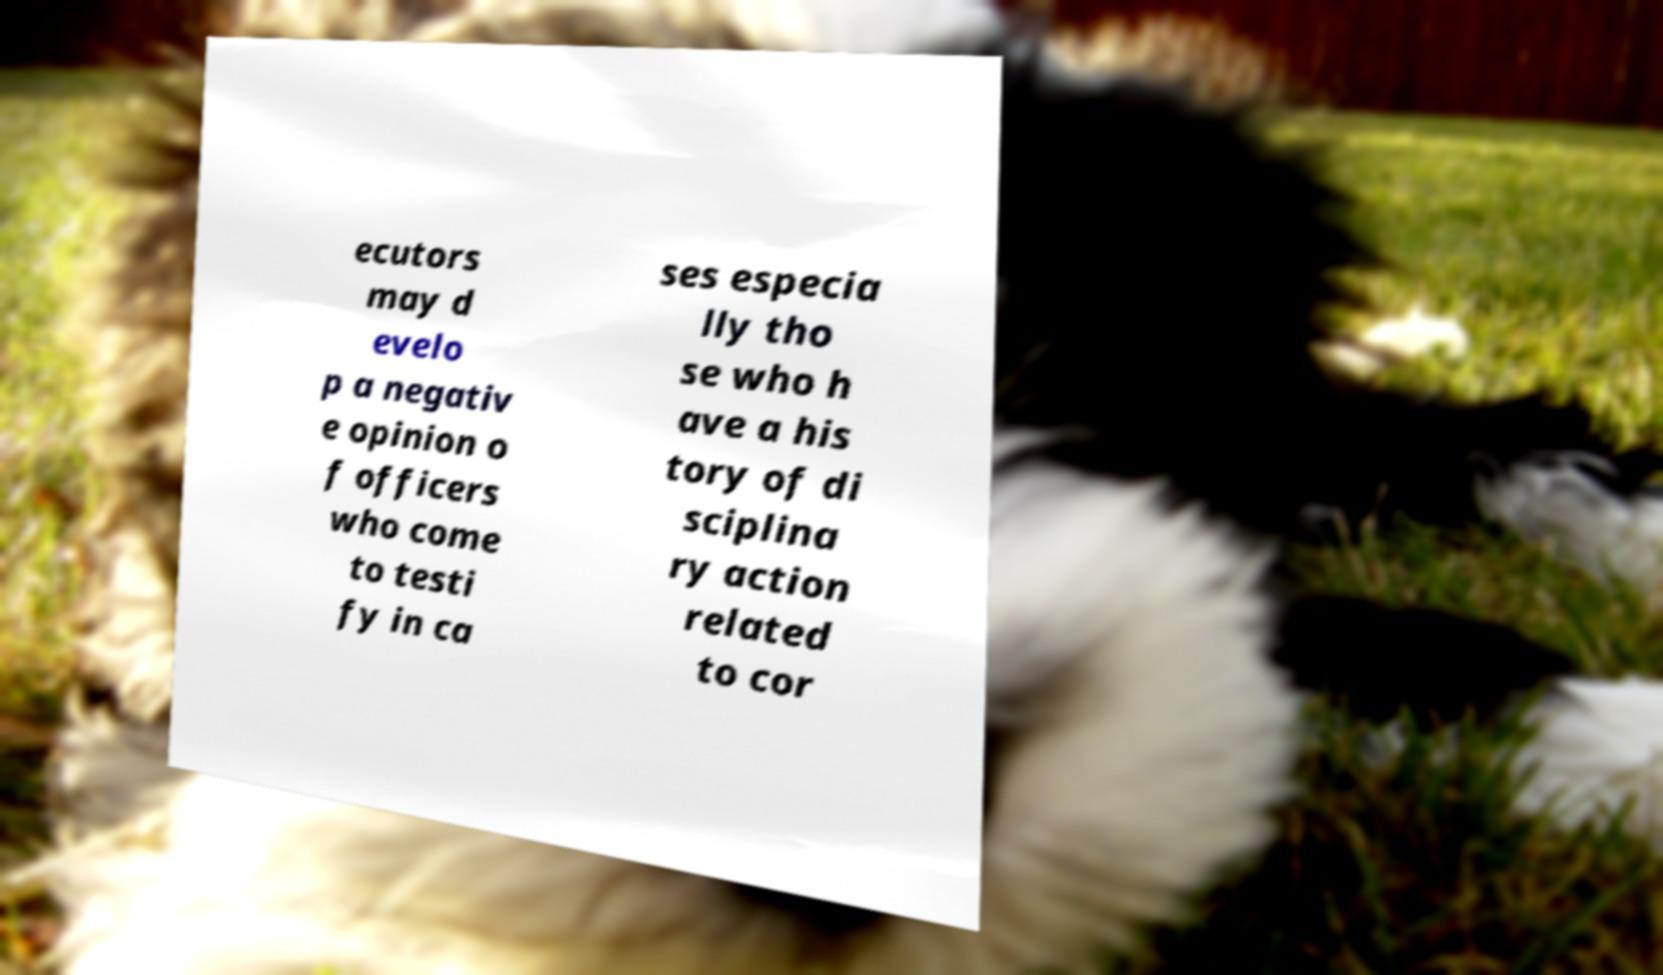Can you read and provide the text displayed in the image?This photo seems to have some interesting text. Can you extract and type it out for me? ecutors may d evelo p a negativ e opinion o f officers who come to testi fy in ca ses especia lly tho se who h ave a his tory of di sciplina ry action related to cor 